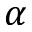<formula> <loc_0><loc_0><loc_500><loc_500>\alpha</formula> 